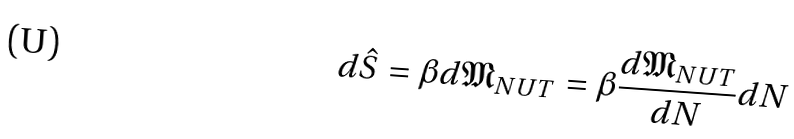<formula> <loc_0><loc_0><loc_500><loc_500>d \hat { S } = \beta d \mathfrak { M } _ { N U T } = \beta \frac { d \mathfrak { M } _ { N U T } } { d N } d N</formula> 